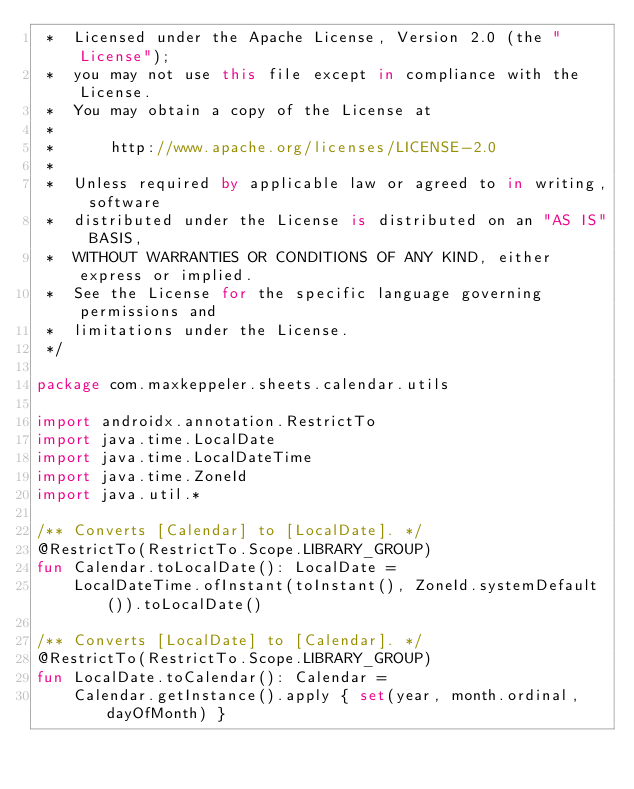Convert code to text. <code><loc_0><loc_0><loc_500><loc_500><_Kotlin_> *  Licensed under the Apache License, Version 2.0 (the "License");
 *  you may not use this file except in compliance with the License.
 *  You may obtain a copy of the License at
 *
 *      http://www.apache.org/licenses/LICENSE-2.0
 *
 *  Unless required by applicable law or agreed to in writing, software
 *  distributed under the License is distributed on an "AS IS" BASIS,
 *  WITHOUT WARRANTIES OR CONDITIONS OF ANY KIND, either express or implied.
 *  See the License for the specific language governing permissions and
 *  limitations under the License.
 */

package com.maxkeppeler.sheets.calendar.utils

import androidx.annotation.RestrictTo
import java.time.LocalDate
import java.time.LocalDateTime
import java.time.ZoneId
import java.util.*

/** Converts [Calendar] to [LocalDate]. */
@RestrictTo(RestrictTo.Scope.LIBRARY_GROUP)
fun Calendar.toLocalDate(): LocalDate =
    LocalDateTime.ofInstant(toInstant(), ZoneId.systemDefault()).toLocalDate()

/** Converts [LocalDate] to [Calendar]. */
@RestrictTo(RestrictTo.Scope.LIBRARY_GROUP)
fun LocalDate.toCalendar(): Calendar =
    Calendar.getInstance().apply { set(year, month.ordinal, dayOfMonth) }

</code> 